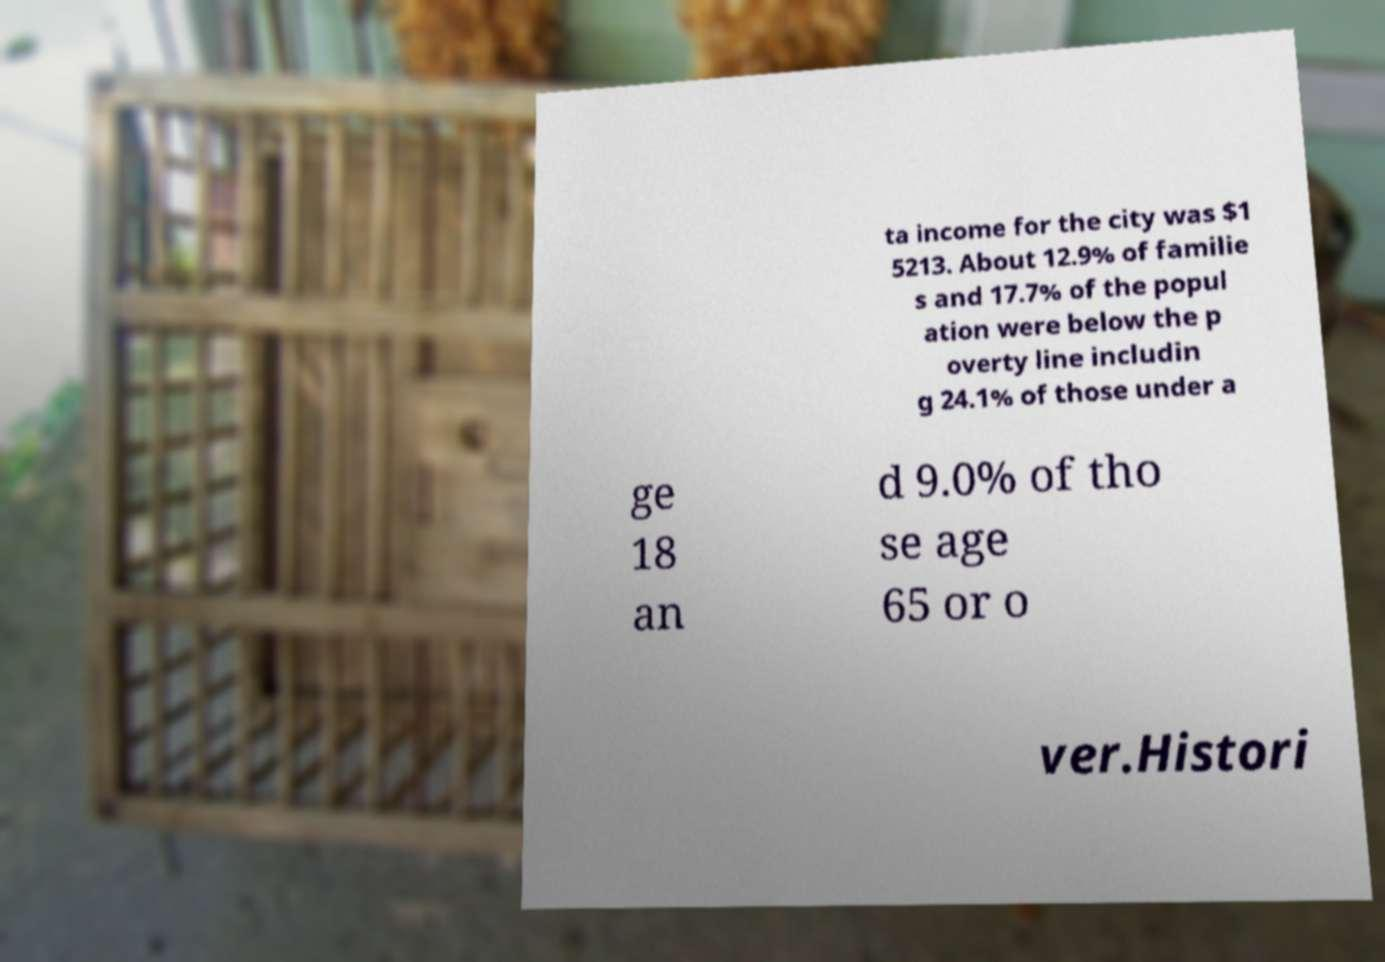Can you read and provide the text displayed in the image?This photo seems to have some interesting text. Can you extract and type it out for me? ta income for the city was $1 5213. About 12.9% of familie s and 17.7% of the popul ation were below the p overty line includin g 24.1% of those under a ge 18 an d 9.0% of tho se age 65 or o ver.Histori 